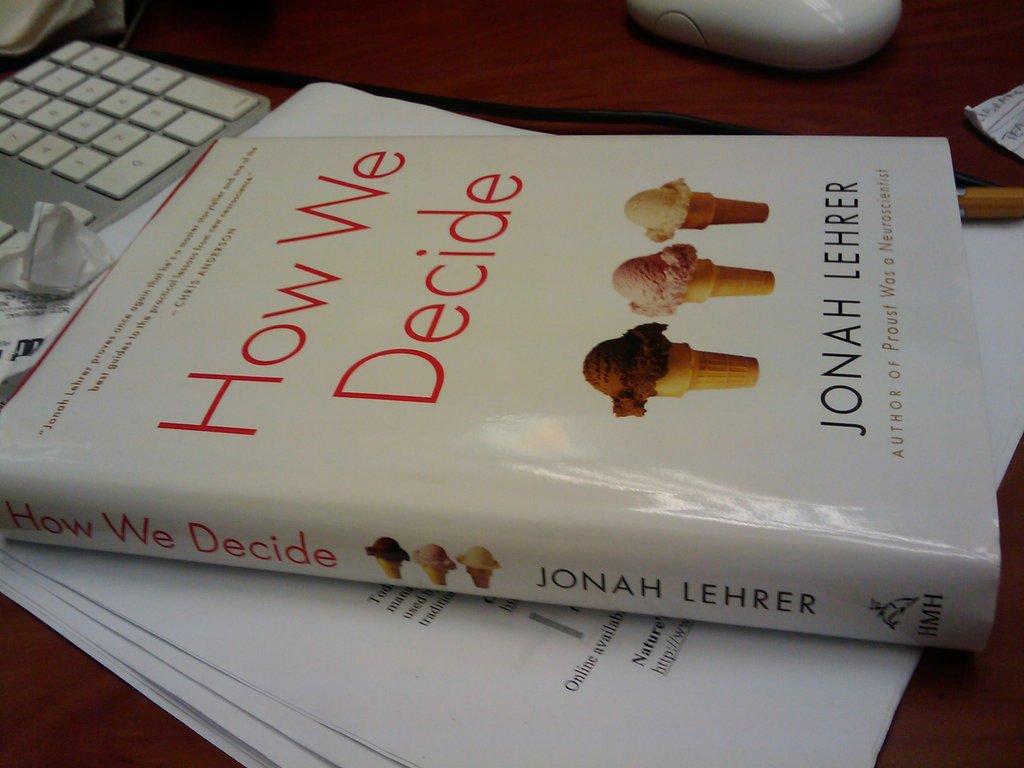What is the title of this book by jonah lehrer?
Make the answer very short. How we decide. Who published this book?
Your answer should be compact. Hmh. 